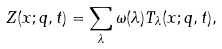<formula> <loc_0><loc_0><loc_500><loc_500>Z ( x ; q , t ) = \sum _ { \lambda } \omega ( \lambda ) T _ { \lambda } ( x ; q , t ) ,</formula> 